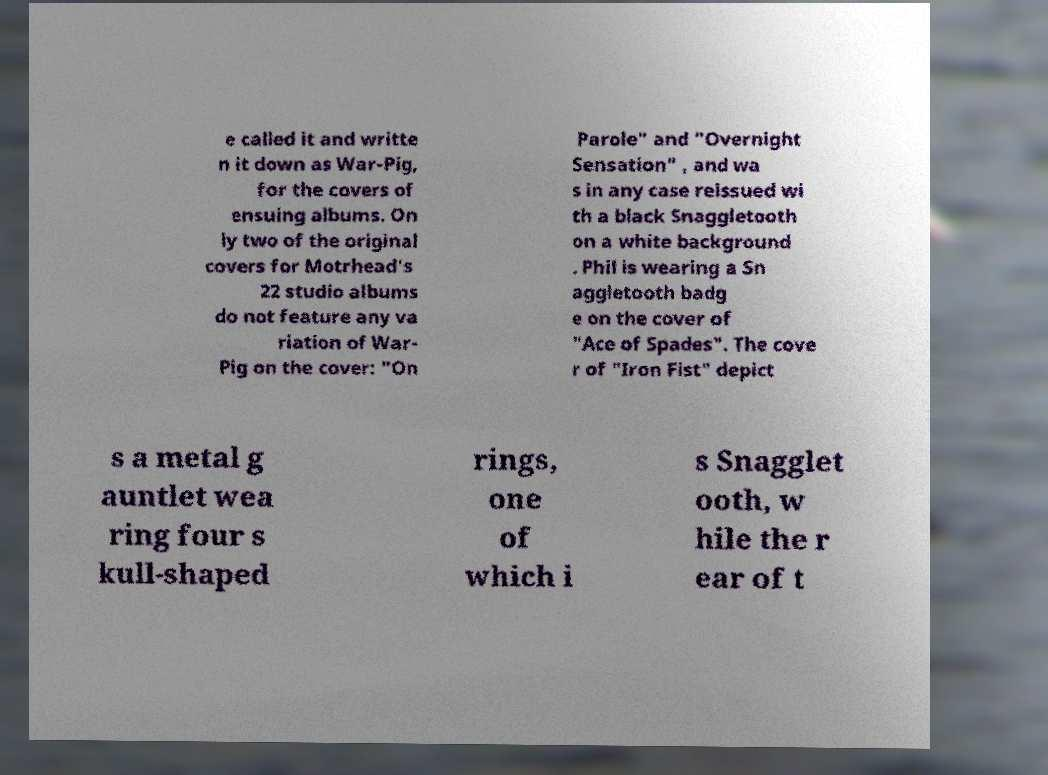What messages or text are displayed in this image? I need them in a readable, typed format. e called it and writte n it down as War-Pig, for the covers of ensuing albums. On ly two of the original covers for Motrhead's 22 studio albums do not feature any va riation of War- Pig on the cover: "On Parole" and "Overnight Sensation" , and wa s in any case reissued wi th a black Snaggletooth on a white background . Phil is wearing a Sn aggletooth badg e on the cover of "Ace of Spades". The cove r of "Iron Fist" depict s a metal g auntlet wea ring four s kull-shaped rings, one of which i s Snagglet ooth, w hile the r ear of t 